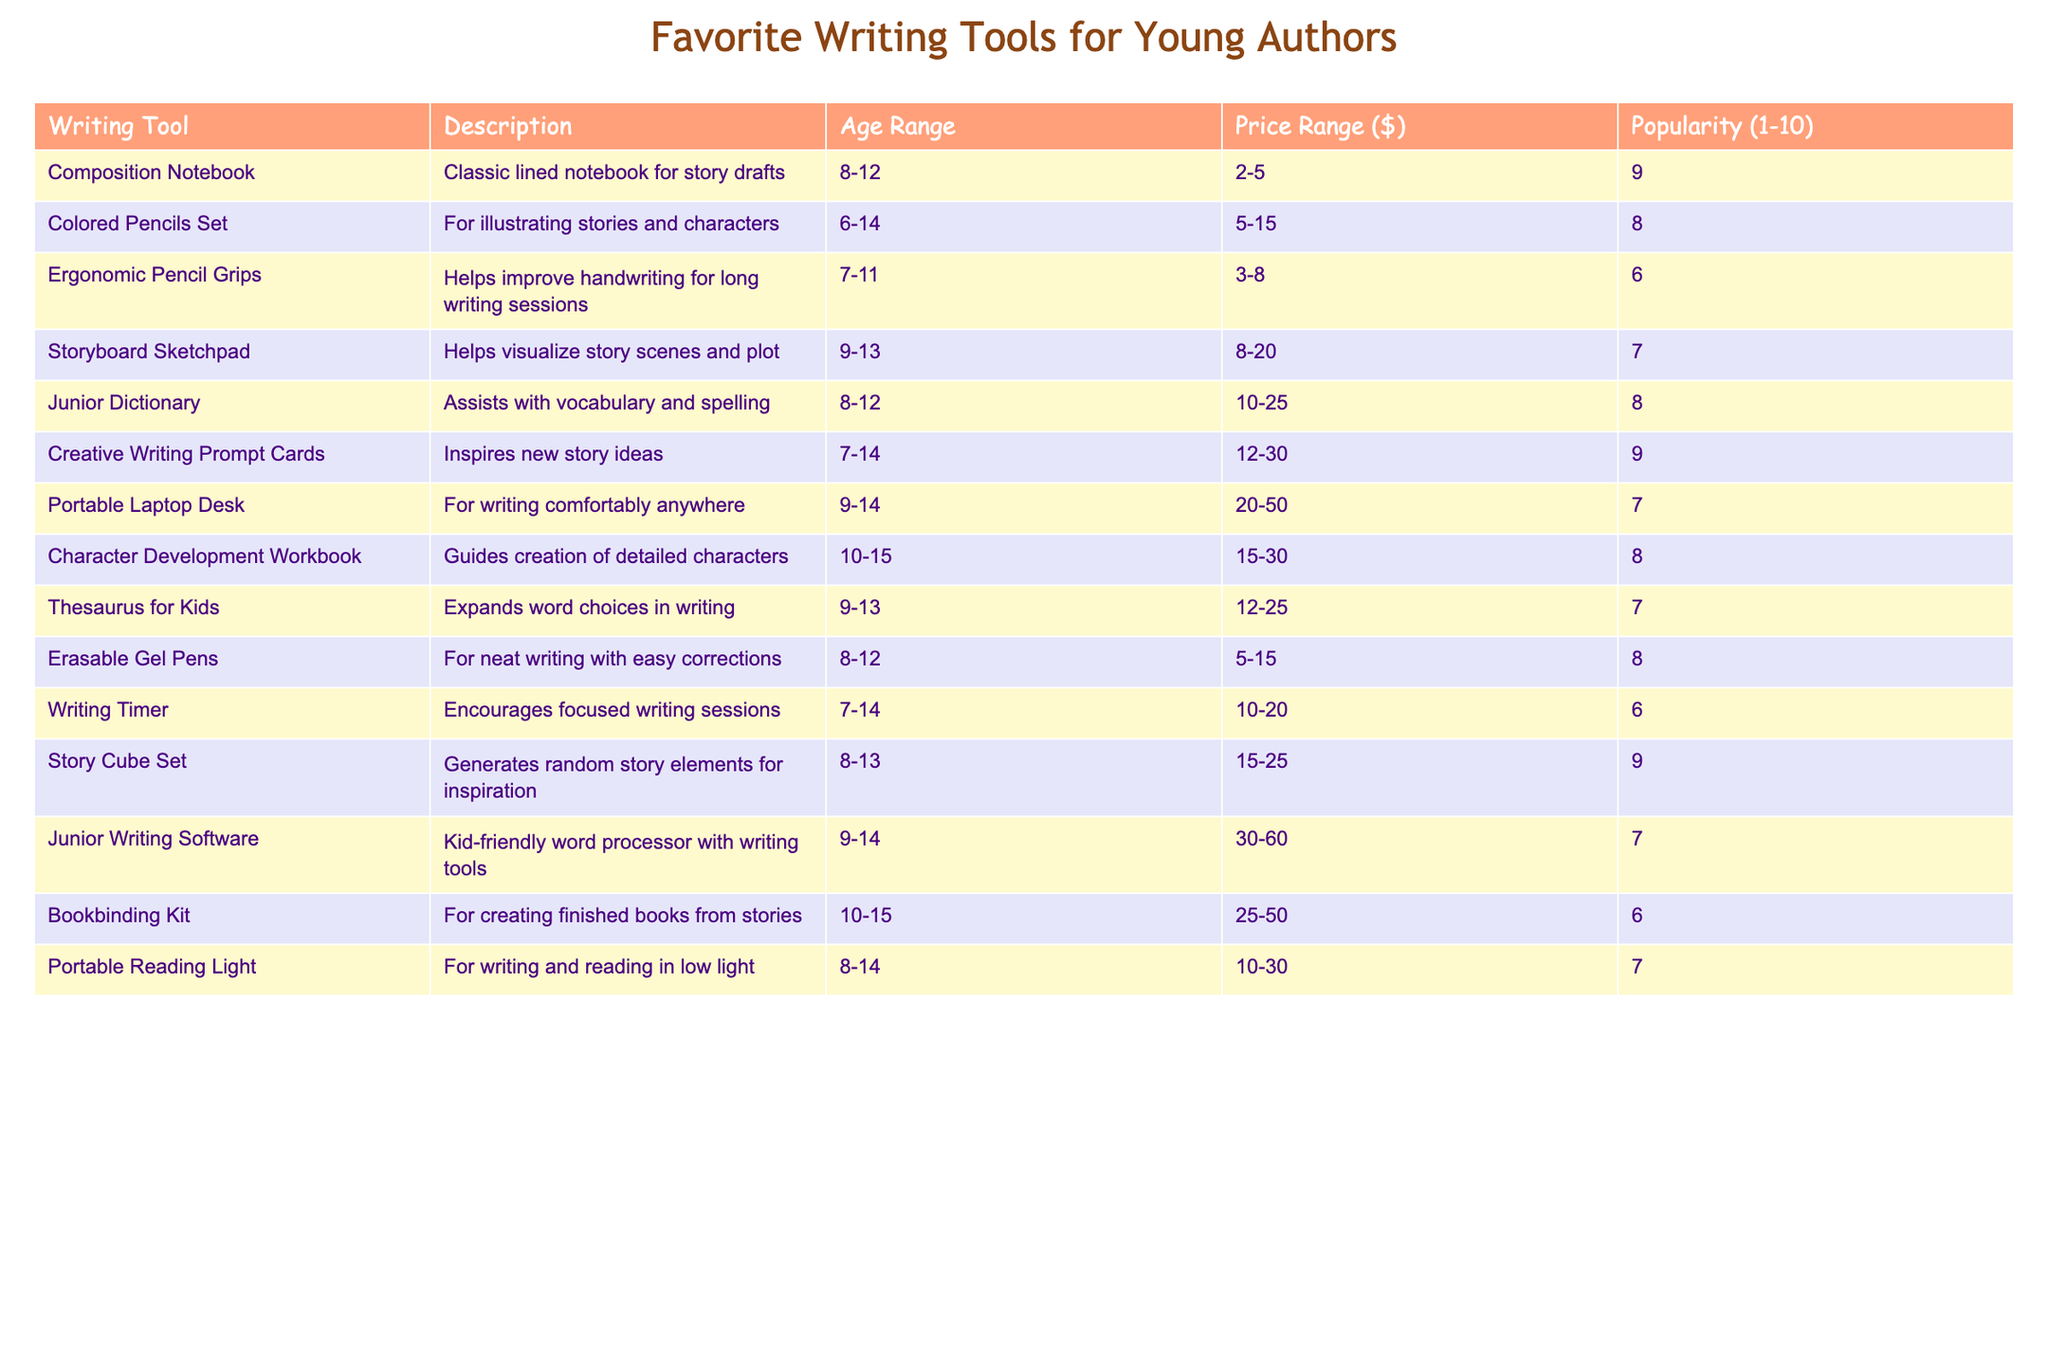What is the most popular writing tool for young authors? The tool with the highest popularity rating is the Composition Notebook, which has a rating of 9.
Answer: Composition Notebook How many writing tools are suitable for ages 10 to 15? There are 4 writing tools listed that have an age range including 10 to 15 years: Character Development Workbook, Bookbinding Kit, Creative Writing Prompt Cards, and Story Cube Set.
Answer: 4 Is the Portable Laptop Desk more expensive than the Junior Dictionary? The Portable Laptop Desk has a price range of $20 to $50, while the Junior Dictionary's price range is $10 to $25. Since $20 is greater than $25, the statement is true.
Answer: Yes Which writing tool has the lowest popularity rating? The Ergonomic Pencil Grips and Bookbinding Kit both have the lowest popularity rating of 6.
Answer: Ergonomic Pencil Grips and Bookbinding Kit What is the average price range of writing tools that have a popularity rating of 8? The tools with a rating of 8 are: Colored Pencils Set ($5 to $15), Junior Dictionary ($10 to $25), Erasable Gel Pens ($5 to $15), and Creative Writing Prompt Cards ($12 to $30). To find the average, we take the average of the ranges: (10, 20) and find the average value which is $12.5 to $22.5. Thus, the final average price range is approximately $11.25 to $22.5.
Answer: $11.25 to $22.5 How many tools are primarily for visual aids, like drawing or sketching? The tools for visual aids are Colored Pencils Set, Storyboard Sketchpad, and Story Cube Set. That gives a total of 3 tools focused on illustration and visualization.
Answer: 3 What percentage of writing tools are aimed at ages 8 to 12? There are 6 writing tools suitable for the 8 to 12 age range out of a total of 15 tools. Calculating the percentage gives (6/15) * 100 = 40%.
Answer: 40% Which writing tool is specifically designed to help with vocabulary? The Junior Dictionary is designed to assist with vocabulary and spelling.
Answer: Junior Dictionary How many tools have price ranges that go above $30? The tools with price ranges above $30 are the Portable Laptop Desk ($20 to $50), Junior Writing Software ($30 to $60), and Bookbinding Kit ($25 to $50), giving a total of 3 tools.
Answer: 3 Are there any tools with a popularity rating of 7? Yes, there are 4 tools listed with a popularity rating of 7: Storyboard Sketchpad, Thesaurus for Kids, Portable Reading Light, and Junior Writing Software.
Answer: Yes If I wanted to use a writing tool to help improve handwriting, which one would I choose? You would choose the Ergonomic Pencil Grips, as it is specifically designed to help improve handwriting for long writing sessions.
Answer: Ergonomic Pencil Grips 